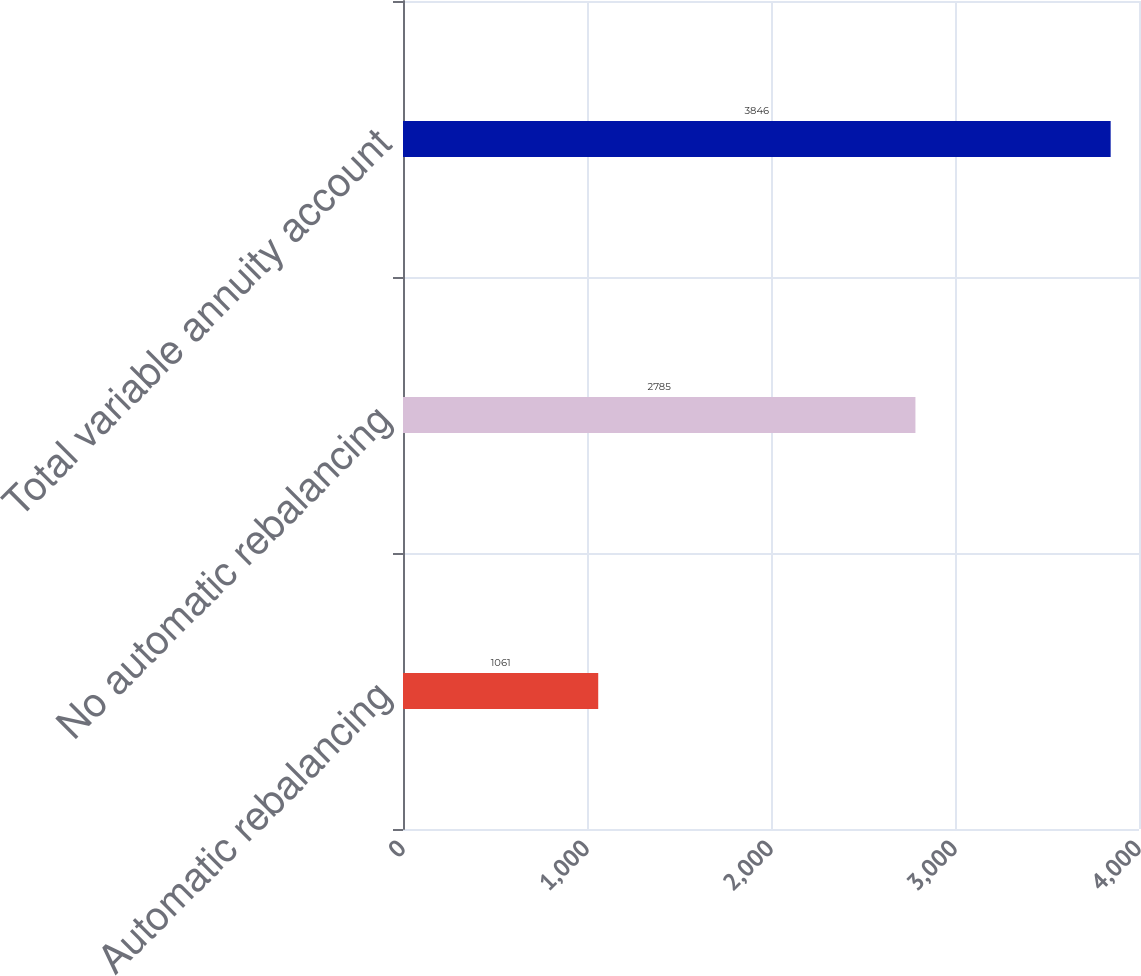<chart> <loc_0><loc_0><loc_500><loc_500><bar_chart><fcel>Automatic rebalancing<fcel>No automatic rebalancing<fcel>Total variable annuity account<nl><fcel>1061<fcel>2785<fcel>3846<nl></chart> 